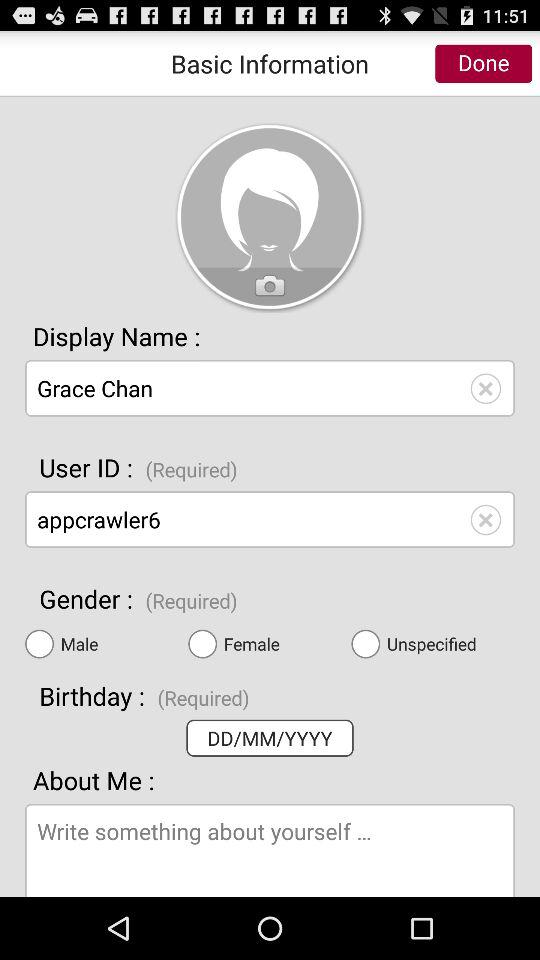What is the name of the user? The name of the user is Grace Chan. 